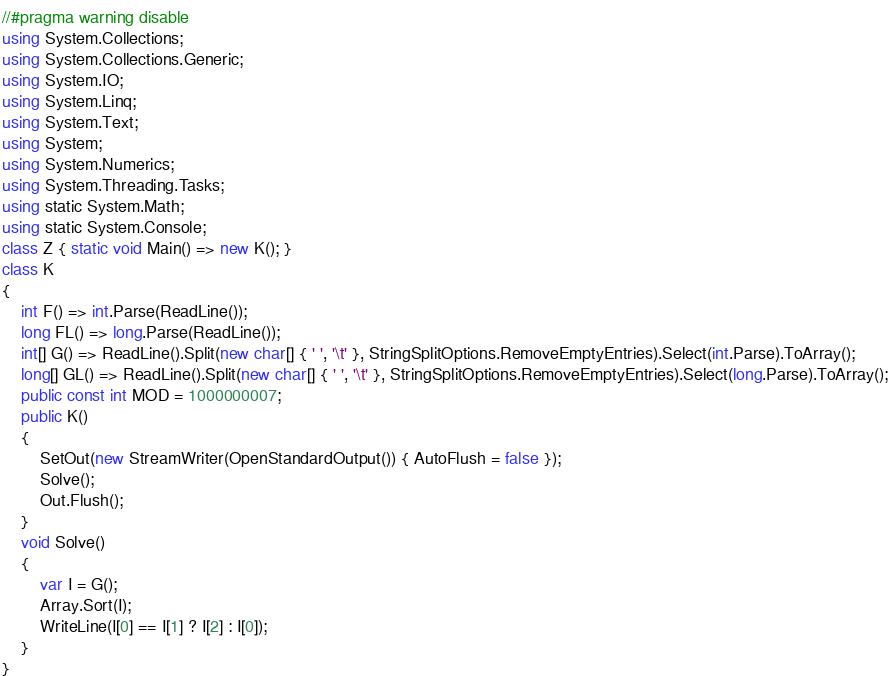<code> <loc_0><loc_0><loc_500><loc_500><_C#_>//#pragma warning disable
using System.Collections;
using System.Collections.Generic;
using System.IO;
using System.Linq;
using System.Text;
using System;
using System.Numerics;
using System.Threading.Tasks;
using static System.Math;
using static System.Console;
class Z { static void Main() => new K(); }
class K
{
	int F() => int.Parse(ReadLine());
	long FL() => long.Parse(ReadLine());
	int[] G() => ReadLine().Split(new char[] { ' ', '\t' }, StringSplitOptions.RemoveEmptyEntries).Select(int.Parse).ToArray();
	long[] GL() => ReadLine().Split(new char[] { ' ', '\t' }, StringSplitOptions.RemoveEmptyEntries).Select(long.Parse).ToArray();
	public const int MOD = 1000000007;
	public K()
	{
		SetOut(new StreamWriter(OpenStandardOutput()) { AutoFlush = false });
		Solve();
		Out.Flush();
	}
	void Solve()
	{
		var I = G();
		Array.Sort(I);
		WriteLine(I[0] == I[1] ? I[2] : I[0]);
	}
}
</code> 